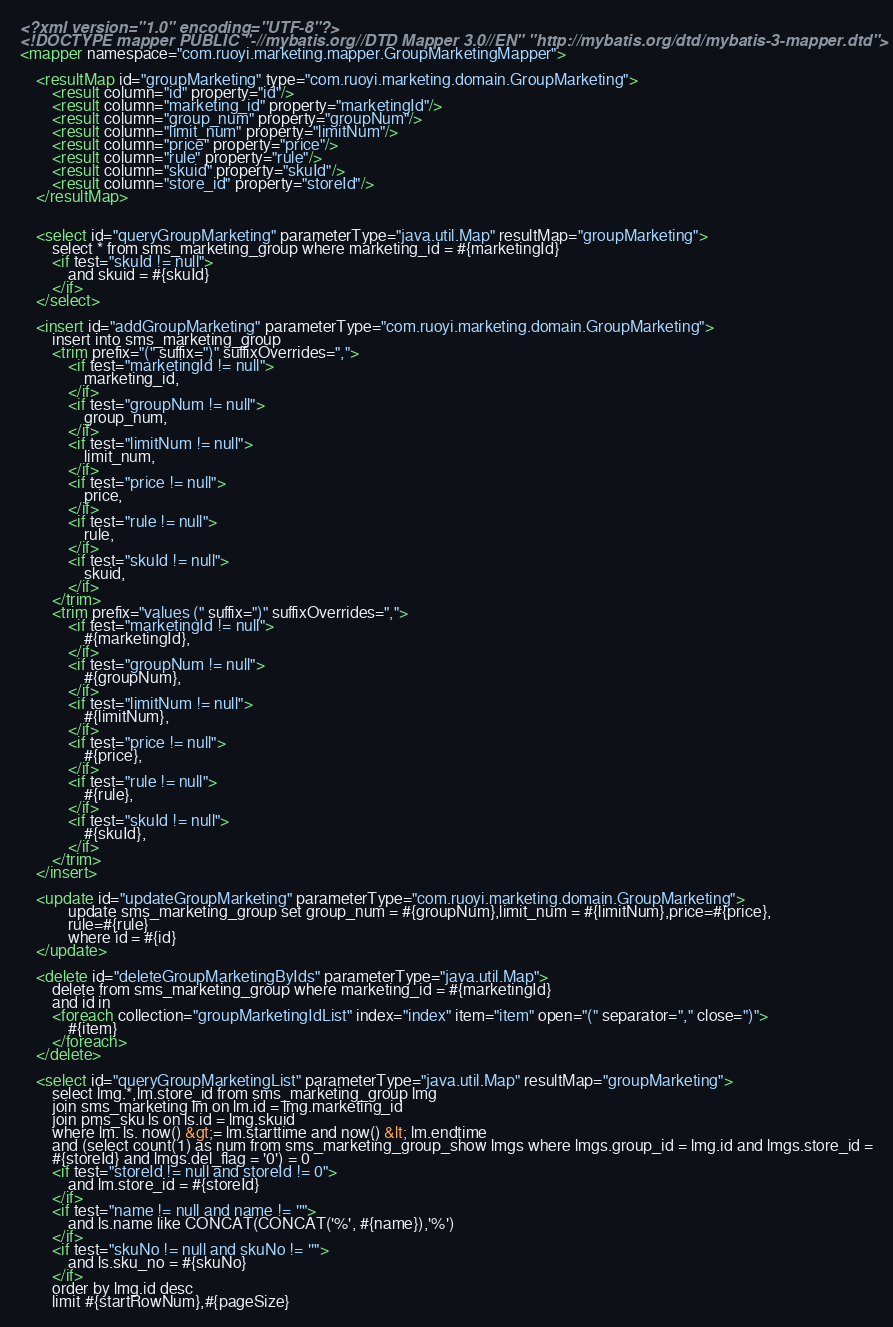Convert code to text. <code><loc_0><loc_0><loc_500><loc_500><_XML_><?xml version="1.0" encoding="UTF-8"?>
<!DOCTYPE mapper PUBLIC "-//mybatis.org//DTD Mapper 3.0//EN" "http://mybatis.org/dtd/mybatis-3-mapper.dtd">
<mapper namespace="com.ruoyi.marketing.mapper.GroupMarketingMapper">

    <resultMap id="groupMarketing" type="com.ruoyi.marketing.domain.GroupMarketing">
        <result column="id" property="id"/>
        <result column="marketing_id" property="marketingId"/>
        <result column="group_num" property="groupNum"/>
        <result column="limit_num" property="limitNum"/>
        <result column="price" property="price"/>
        <result column="rule" property="rule"/>
        <result column="skuid" property="skuId"/>
        <result column="store_id" property="storeId"/>
    </resultMap>


    <select id="queryGroupMarketing" parameterType="java.util.Map" resultMap="groupMarketing">
        select * from sms_marketing_group where marketing_id = #{marketingId}
        <if test="skuId != null">
            and skuid = #{skuId}
        </if>
    </select>

    <insert id="addGroupMarketing" parameterType="com.ruoyi.marketing.domain.GroupMarketing">
        insert into sms_marketing_group
        <trim prefix="(" suffix=")" suffixOverrides=",">
            <if test="marketingId != null">
                marketing_id,
            </if>
            <if test="groupNum != null">
                group_num,
            </if>
            <if test="limitNum != null">
                limit_num,
            </if>
            <if test="price != null">
                price,
            </if>
            <if test="rule != null">
                rule,
            </if>
            <if test="skuId != null">
                skuid,
            </if>
        </trim>
        <trim prefix="values (" suffix=")" suffixOverrides=",">
            <if test="marketingId != null">
                #{marketingId},
            </if>
            <if test="groupNum != null">
                #{groupNum},
            </if>
            <if test="limitNum != null">
                #{limitNum},
            </if>
            <if test="price != null">
                #{price},
            </if>
            <if test="rule != null">
                #{rule},
            </if>
            <if test="skuId != null">
                #{skuId},
            </if>
        </trim>
    </insert>

    <update id="updateGroupMarketing" parameterType="com.ruoyi.marketing.domain.GroupMarketing">
            update sms_marketing_group set group_num = #{groupNum},limit_num = #{limitNum},price=#{price},
            rule=#{rule}
            where id = #{id}
    </update>

    <delete id="deleteGroupMarketingByIds" parameterType="java.util.Map">
        delete from sms_marketing_group where marketing_id = #{marketingId}
        and id in
        <foreach collection="groupMarketingIdList" index="index" item="item" open="(" separator="," close=")">
            #{item}
        </foreach>
    </delete>

    <select id="queryGroupMarketingList" parameterType="java.util.Map" resultMap="groupMarketing">
        select lmg.*,lm.store_id from sms_marketing_group lmg
        join sms_marketing lm on lm.id = lmg.marketing_id
        join pms_sku ls on ls.id = lmg.skuid
        where lm. ls. now() &gt;= lm.starttime and now() &lt; lm.endtime
        and (select count(1) as num from sms_marketing_group_show lmgs where lmgs.group_id = lmg.id and lmgs.store_id =
        #{storeId} and lmgs.del_flag = '0') = 0
        <if test="storeId != null and storeId != 0">
            and lm.store_id = #{storeId}
        </if>
        <if test="name != null and name != ''">
            and ls.name like CONCAT(CONCAT('%', #{name}),'%')
        </if>
        <if test="skuNo != null and skuNo != ''">
            and ls.sku_no = #{skuNo}
        </if>
        order by lmg.id desc
        limit #{startRowNum},#{pageSize}</code> 